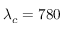Convert formula to latex. <formula><loc_0><loc_0><loc_500><loc_500>\lambda _ { c } = 7 8 0</formula> 